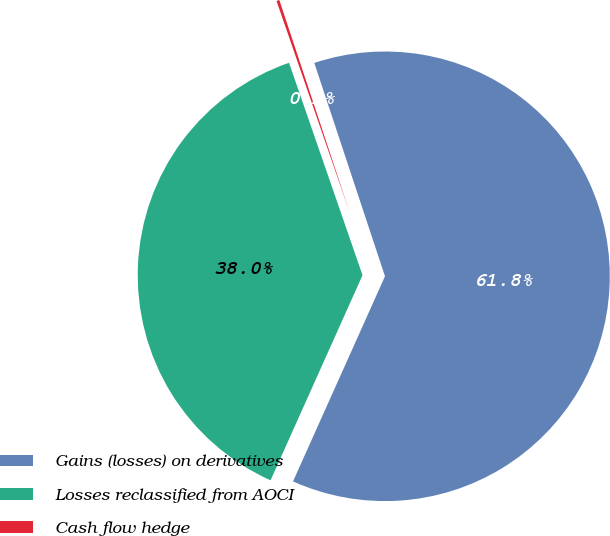Convert chart. <chart><loc_0><loc_0><loc_500><loc_500><pie_chart><fcel>Gains (losses) on derivatives<fcel>Losses reclassified from AOCI<fcel>Cash flow hedge<nl><fcel>61.8%<fcel>37.99%<fcel>0.21%<nl></chart> 